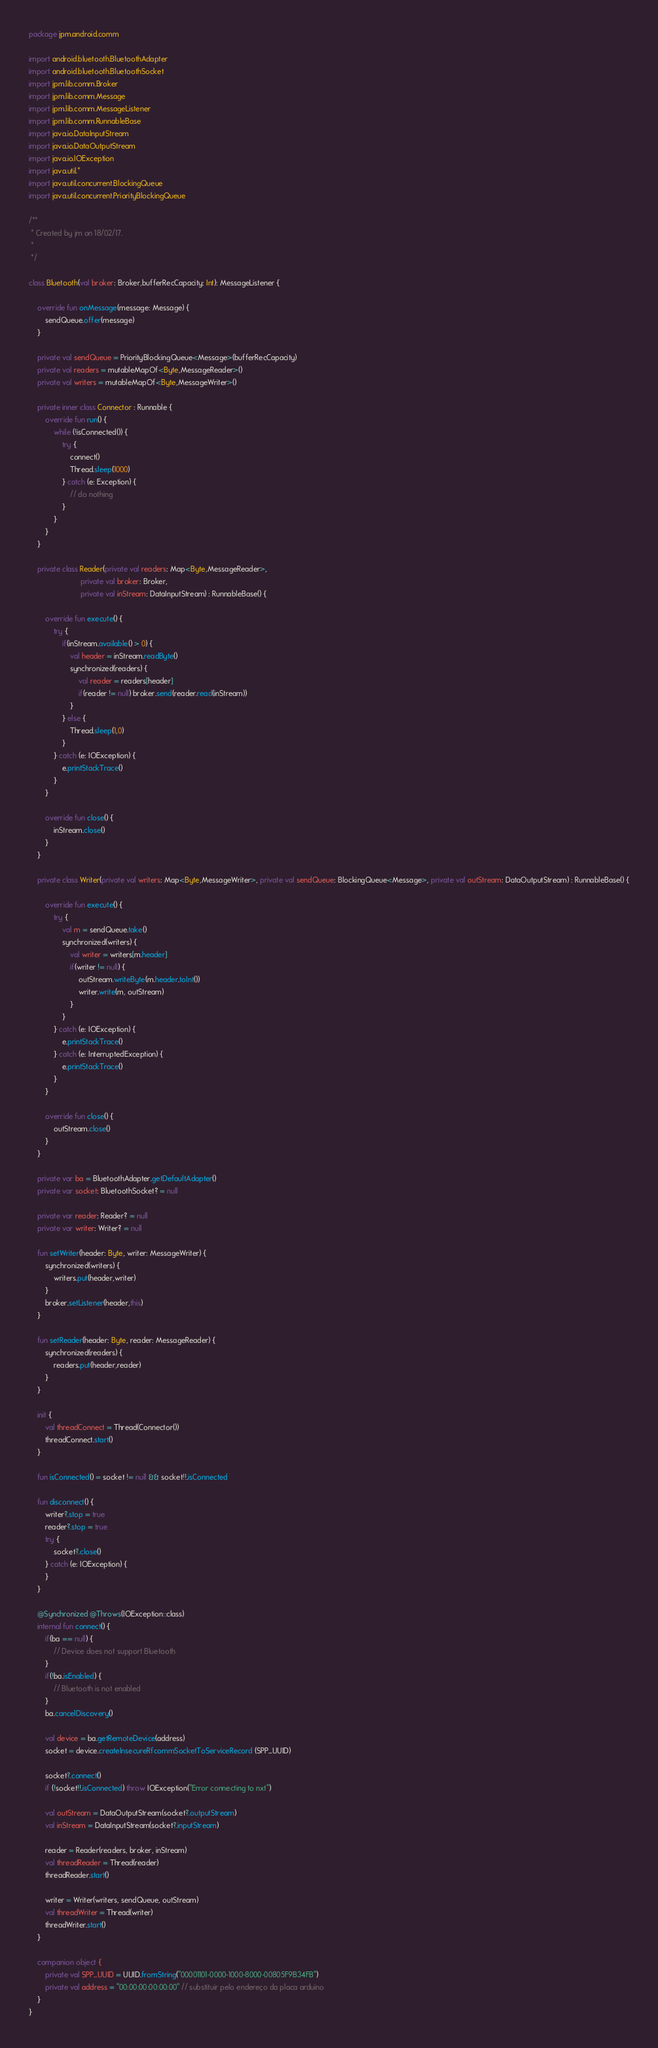<code> <loc_0><loc_0><loc_500><loc_500><_Kotlin_>package jpm.android.comm

import android.bluetooth.BluetoothAdapter
import android.bluetooth.BluetoothSocket
import jpm.lib.comm.Broker
import jpm.lib.comm.Message
import jpm.lib.comm.MessageListener
import jpm.lib.comm.RunnableBase
import java.io.DataInputStream
import java.io.DataOutputStream
import java.io.IOException
import java.util.*
import java.util.concurrent.BlockingQueue
import java.util.concurrent.PriorityBlockingQueue

/**
 * Created by jm on 18/02/17.
 *
 */

class Bluetooth(val broker: Broker,bufferRecCapacity: Int): MessageListener {

    override fun onMessage(message: Message) {
        sendQueue.offer(message)
    }

    private val sendQueue = PriorityBlockingQueue<Message>(bufferRecCapacity)
    private val readers = mutableMapOf<Byte,MessageReader>()
    private val writers = mutableMapOf<Byte,MessageWriter>()

    private inner class Connector : Runnable {
        override fun run() {
            while (!isConnected()) {
                try {
                    connect()
                    Thread.sleep(1000)
                } catch (e: Exception) {
                    // do nothing
                }
            }
        }
    }

    private class Reader(private val readers: Map<Byte,MessageReader>,
                         private val broker: Broker,
                         private val inStream: DataInputStream) : RunnableBase() {

        override fun execute() {
            try {
                if(inStream.available() > 0) {
                    val header = inStream.readByte()
                    synchronized(readers) {
                        val reader = readers[header]
                        if(reader != null) broker.send(reader.read(inStream))
                    }
                } else {
                    Thread.sleep(1,0)
                }
            } catch (e: IOException) {
                e.printStackTrace()
            }
        }

        override fun close() {
            inStream.close()
        }
    }

    private class Writer(private val writers: Map<Byte,MessageWriter>, private val sendQueue: BlockingQueue<Message>, private val outStream: DataOutputStream) : RunnableBase() {

        override fun execute() {
            try {
                val m = sendQueue.take()
                synchronized(writers) {
                    val writer = writers[m.header]
                    if(writer != null) {
                        outStream.writeByte(m.header.toInt())
                        writer.write(m, outStream)
                    }
                }
            } catch (e: IOException) {
                e.printStackTrace()
            } catch (e: InterruptedException) {
                e.printStackTrace()
            }
        }

        override fun close() {
            outStream.close()
        }
    }

    private var ba = BluetoothAdapter.getDefaultAdapter()
    private var socket: BluetoothSocket? = null

    private var reader: Reader? = null
    private var writer: Writer? = null

    fun setWriter(header: Byte, writer: MessageWriter) {
        synchronized(writers) {
            writers.put(header,writer)
        }
        broker.setListener(header,this)
    }

    fun setReader(header: Byte, reader: MessageReader) {
        synchronized(readers) {
            readers.put(header,reader)
        }
    }

    init {
        val threadConnect = Thread(Connector())
        threadConnect.start()
    }

    fun isConnected() = socket != null && socket!!.isConnected

    fun disconnect() {
        writer?.stop = true
        reader?.stop = true
        try {
            socket?.close()
        } catch (e: IOException) {
        }
    }

    @Synchronized @Throws(IOException::class)
    internal fun connect() {
        if(ba == null) {
            // Device does not support Bluetooth
        }
        if(!ba.isEnabled) {
            // Bluetooth is not enabled
        }
        ba.cancelDiscovery()

        val device = ba.getRemoteDevice(address)
        socket = device.createInsecureRfcommSocketToServiceRecord (SPP_UUID)

        socket?.connect()
        if (!socket!!.isConnected) throw IOException("Error connecting to nxt")

        val outStream = DataOutputStream(socket?.outputStream)
        val inStream = DataInputStream(socket?.inputStream)

        reader = Reader(readers, broker, inStream)
        val threadReader = Thread(reader)
        threadReader.start()

        writer = Writer(writers, sendQueue, outStream)
        val threadWriter = Thread(writer)
        threadWriter.start()
    }

    companion object {
        private val SPP_UUID = UUID.fromString("00001101-0000-1000-8000-00805F9B34FB")
        private val address = "00:00:00:00:00:00" // substituir pelo endereço da placa arduino
    }
}
</code> 